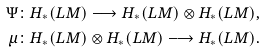<formula> <loc_0><loc_0><loc_500><loc_500>\Psi & \colon H _ { * } ( L M ) \longrightarrow H _ { * } ( L M ) \otimes H _ { * } ( L M ) , \\ \mu & \colon H _ { * } ( L M ) \otimes H _ { * } ( L M ) \longrightarrow H _ { * } ( L M ) .</formula> 